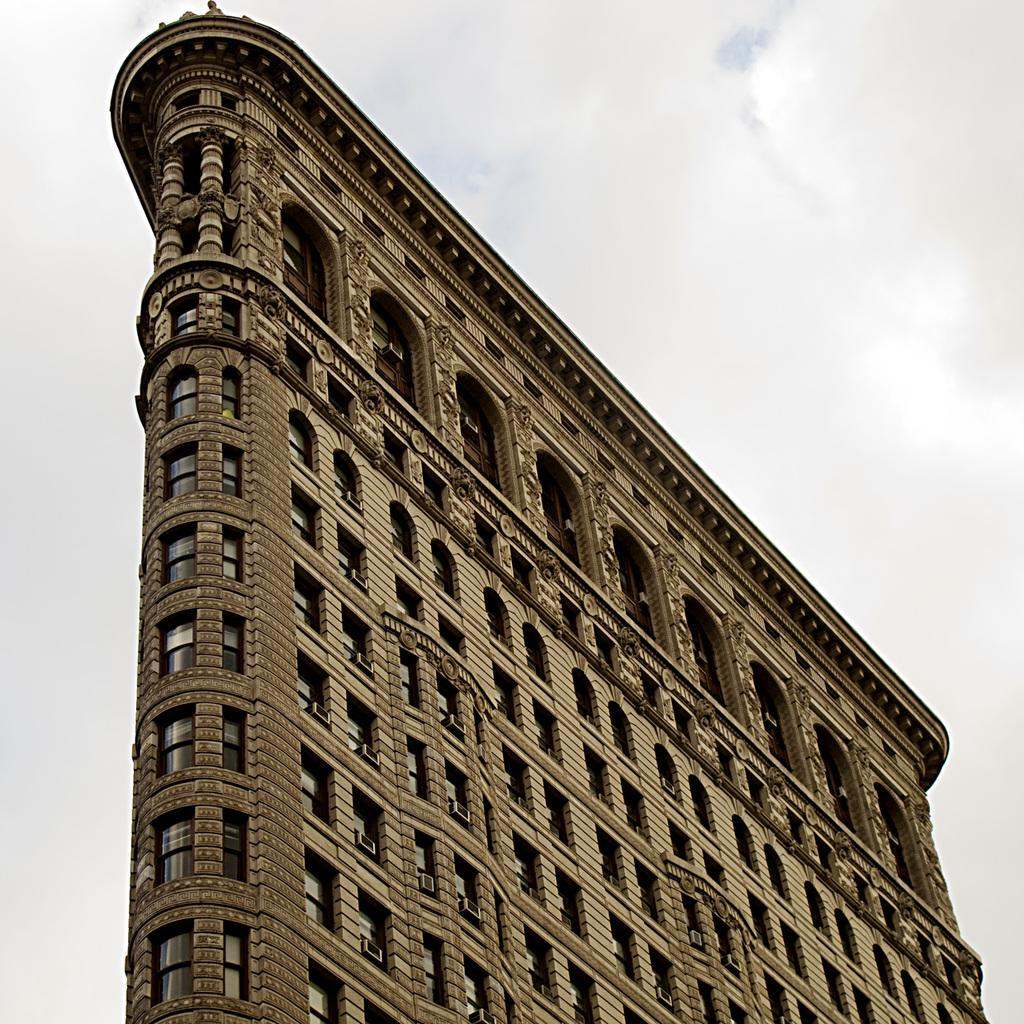What is the main structure in the picture? There is a building in the picture. What can be seen in the sky in the image? Clouds are visible in the sky. What type of material is used for the windows in the building? There are glass windows in the building. How many pages does the stranger lose in the building? There is no stranger or mention of pages lost in the image. 